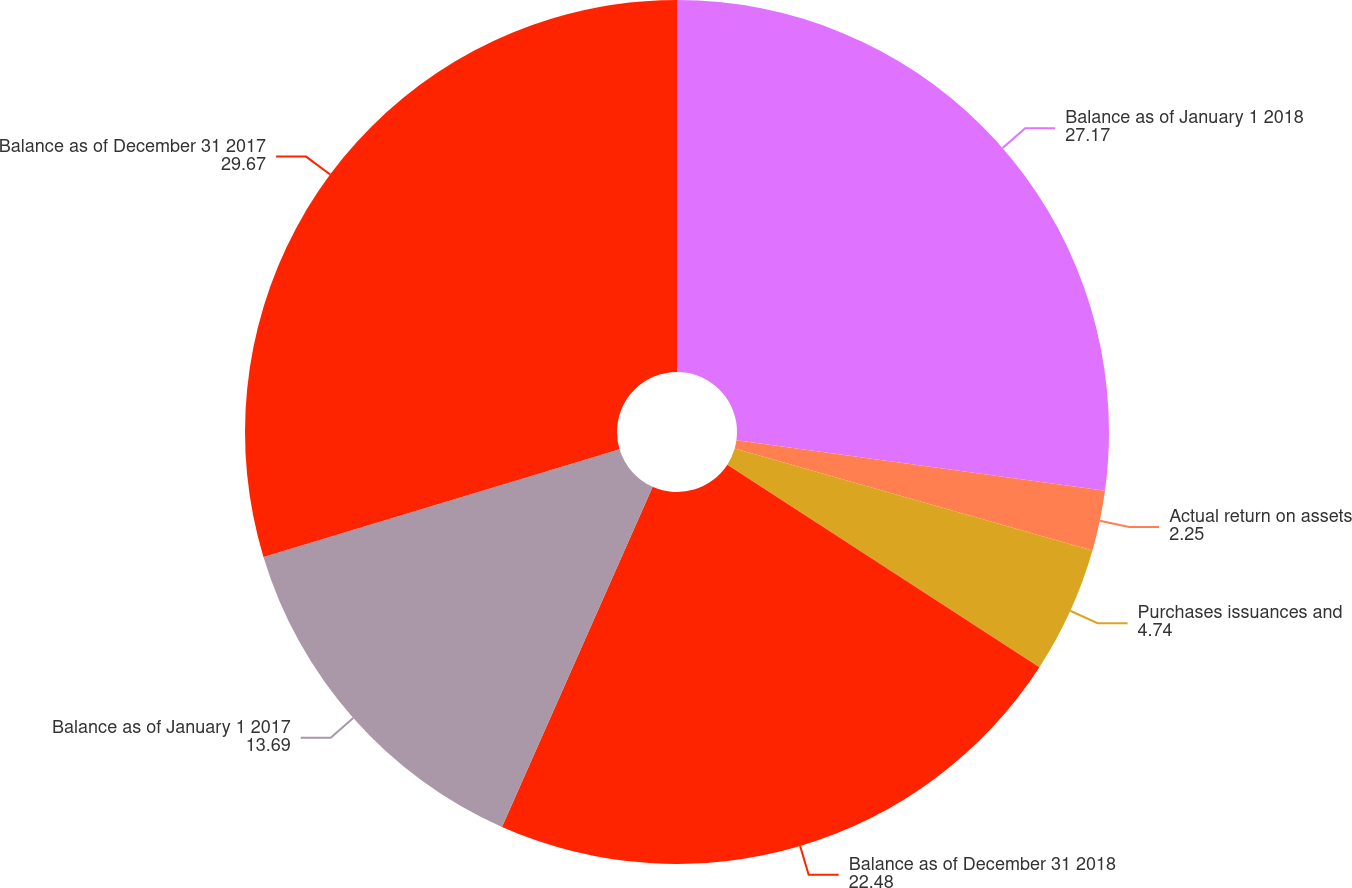Convert chart to OTSL. <chart><loc_0><loc_0><loc_500><loc_500><pie_chart><fcel>Balance as of January 1 2018<fcel>Actual return on assets<fcel>Purchases issuances and<fcel>Balance as of December 31 2018<fcel>Balance as of January 1 2017<fcel>Balance as of December 31 2017<nl><fcel>27.17%<fcel>2.25%<fcel>4.74%<fcel>22.48%<fcel>13.69%<fcel>29.67%<nl></chart> 